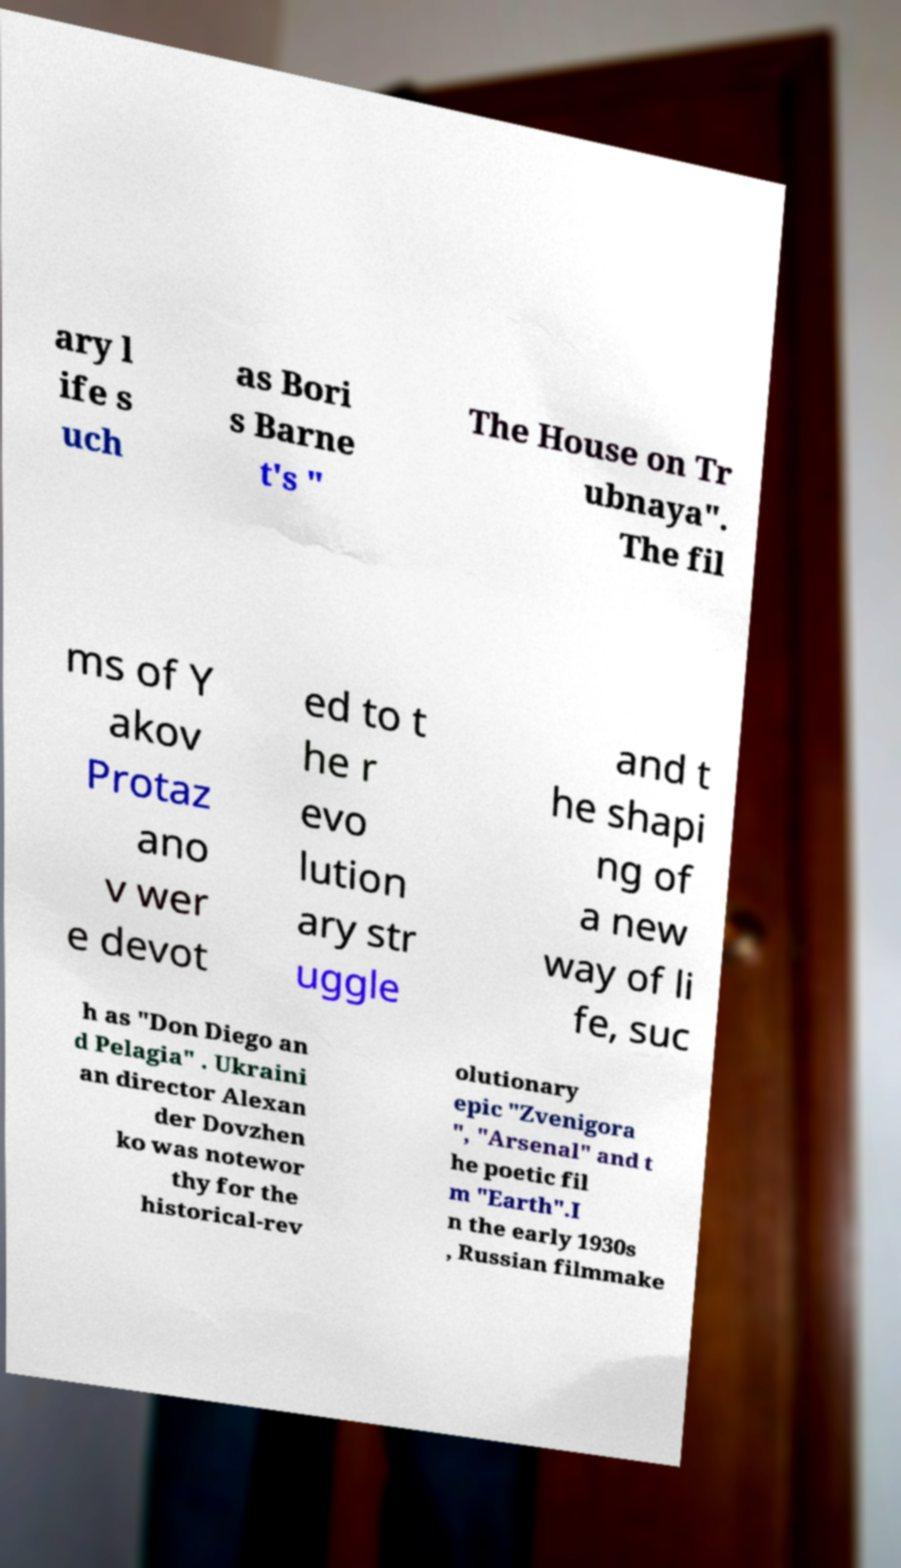For documentation purposes, I need the text within this image transcribed. Could you provide that? ary l ife s uch as Bori s Barne t's " The House on Tr ubnaya". The fil ms of Y akov Protaz ano v wer e devot ed to t he r evo lution ary str uggle and t he shapi ng of a new way of li fe, suc h as "Don Diego an d Pelagia" . Ukraini an director Alexan der Dovzhen ko was notewor thy for the historical-rev olutionary epic "Zvenigora ", "Arsenal" and t he poetic fil m "Earth".I n the early 1930s , Russian filmmake 